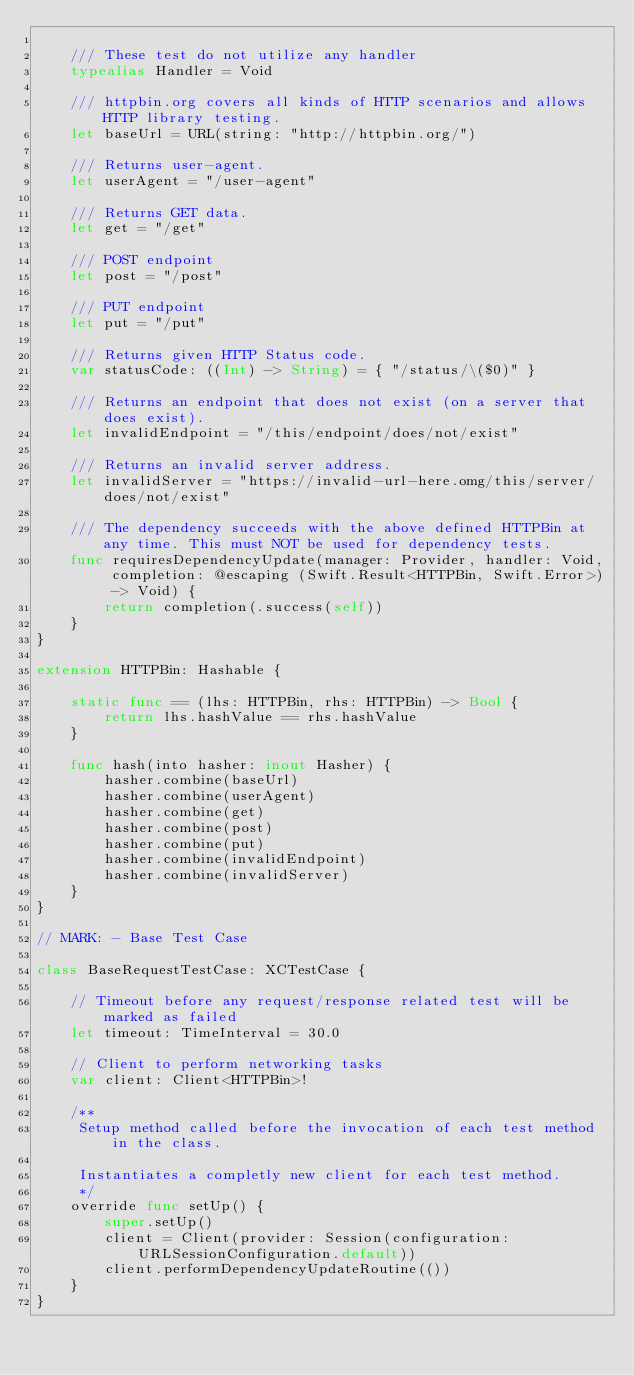Convert code to text. <code><loc_0><loc_0><loc_500><loc_500><_Swift_>
    /// These test do not utilize any handler
    typealias Handler = Void

    /// httpbin.org covers all kinds of HTTP scenarios and allows HTTP library testing.
    let baseUrl = URL(string: "http://httpbin.org/")

    /// Returns user-agent.
    let userAgent = "/user-agent"

    /// Returns GET data.
    let get = "/get"

    /// POST endpoint
    let post = "/post"

    /// PUT endpoint
    let put = "/put"

    /// Returns given HTTP Status code.
    var statusCode: ((Int) -> String) = { "/status/\($0)" }

    /// Returns an endpoint that does not exist (on a server that does exist).
    let invalidEndpoint = "/this/endpoint/does/not/exist"

    /// Returns an invalid server address.
    let invalidServer = "https://invalid-url-here.omg/this/server/does/not/exist"

    /// The dependency succeeds with the above defined HTTPBin at any time. This must NOT be used for dependency tests.
    func requiresDependencyUpdate(manager: Provider, handler: Void, completion: @escaping (Swift.Result<HTTPBin, Swift.Error>) -> Void) {
        return completion(.success(self))
    }
}

extension HTTPBin: Hashable {

    static func == (lhs: HTTPBin, rhs: HTTPBin) -> Bool {
        return lhs.hashValue == rhs.hashValue
    }

    func hash(into hasher: inout Hasher) {
        hasher.combine(baseUrl)
        hasher.combine(userAgent)
        hasher.combine(get)
        hasher.combine(post)
        hasher.combine(put)
        hasher.combine(invalidEndpoint)
        hasher.combine(invalidServer)
    }
}

// MARK: - Base Test Case

class BaseRequestTestCase: XCTestCase {

    // Timeout before any request/response related test will be marked as failed
    let timeout: TimeInterval = 30.0

    // Client to perform networking tasks
    var client: Client<HTTPBin>!

    /**
     Setup method called before the invocation of each test method in the class.

     Instantiates a completly new client for each test method.
     */
    override func setUp() {
        super.setUp()
        client = Client(provider: Session(configuration: URLSessionConfiguration.default))
        client.performDependencyUpdateRoutine(())
    }
}
</code> 